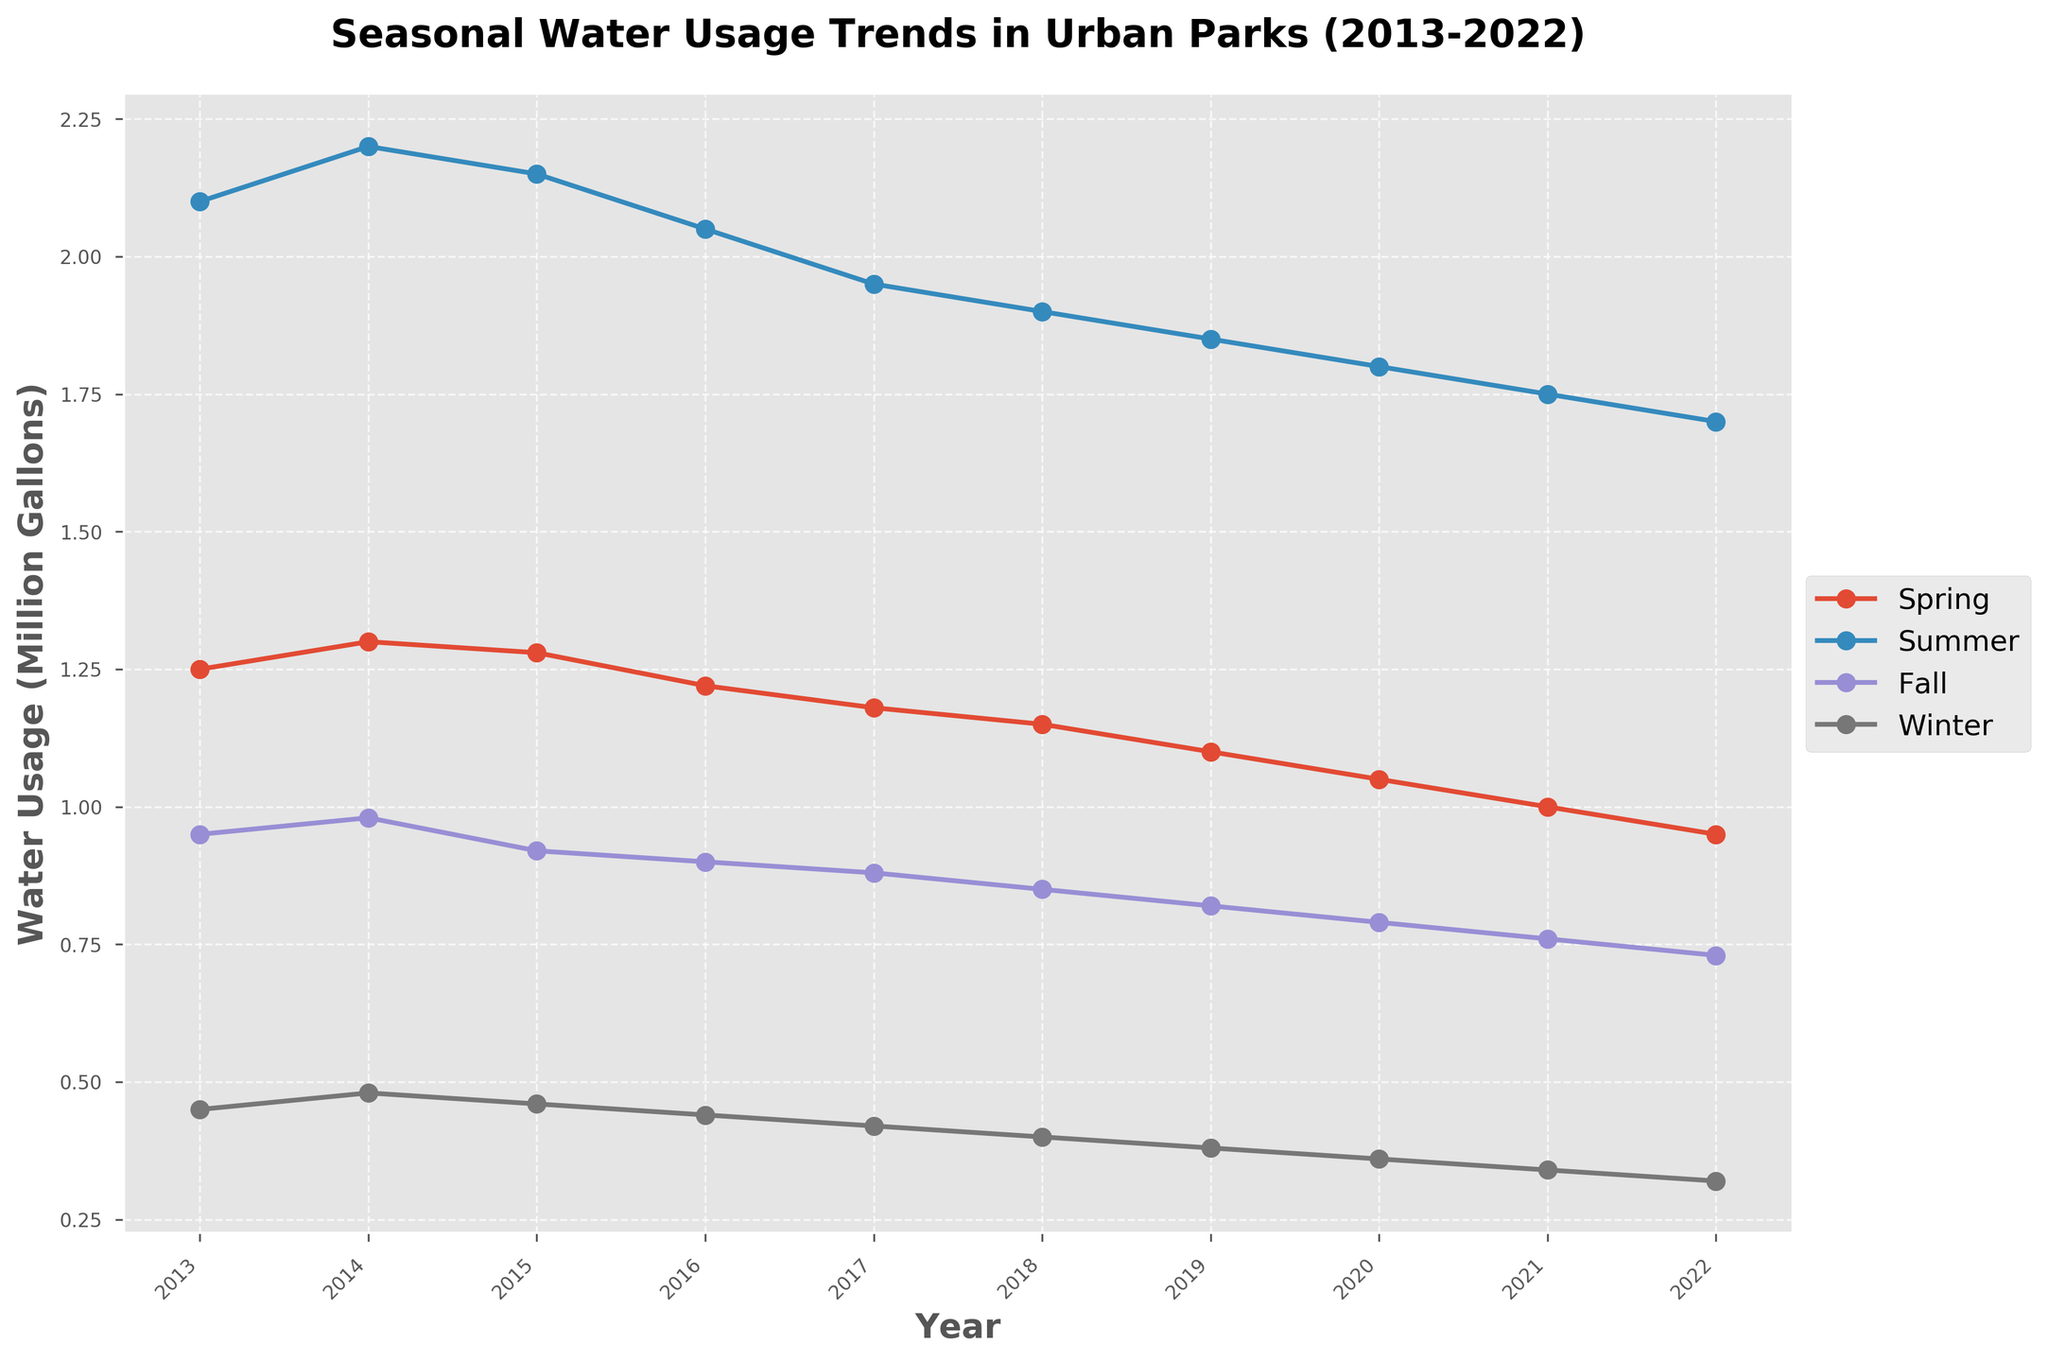What season had the highest water usage in 2013? The plot shows that in 2013, the season with the highest water usage is depicted with the highest peak on the line chart for that year. The highest peak is observed in Summer.
Answer: Summer Which season consistently used the least water across all years? By analyzing the plot, we observe the position of the lines corresponding to each season over the 10-year period. The Winter line is consistently the lowest, indicating the least water usage.
Answer: Winter How did the water usage in Summer change from 2013 to 2022? To determine the change in water usage, we refer to the Summer line on the plot and note the values for 2013 and 2022. The usage starts at a high value in 2013 and shows a gradual decline until 2022.
Answer: Declined What is the average water usage for Spring across the 10 years? We find the data points for Spring on the plot and add them up, then divide by 10. The average calculation is: (1.25 + 1.3 + 1.28 + 1.22 + 1.18 + 1.15 + 1.1 + 1.05 + 1 + 0.95)/10 million gallons.
Answer: 1.148 million gallons Which season shows the most significant reduction in water usage from the maximum to the minimum? By visually inspecting the peaks and troughs of each season on the plot, we can observe that the most dramatic reduction is in Winter, from the highest usage to the lowest usage.
Answer: Winter What was the total water usage in Fall for the years where the usage was below 1 million gallons? Identify the years where Fall's water usage is below 1 million gallons on the plot. Sum these values: 950,000 in 2013, 980,000 in 2014, 920,000 in 2015, 900,000 in 2016, 880,000 in 2017, 850,000 in 2018, 820,000 in 2019, 790,000 in 2020, 760,000 in 2021, and 730,000 in 2022. Total = (950 + 980 + 920 + 900 + 880 + 850 + 820 + 790 + 760 + 730) thousand gallons.
Answer: 8.58 million gallons How does the highest water usage in Spring compare to the highest in Fall? Identify the highest points on the Spring and Fall lines on the plot and compare them. The highest for Spring is in 2014, around 1.3 million gallons, and Fall is in 2014, around 0.98 million gallons.
Answer: Spring is higher What is the difference in water usage between Summer and Winter in 2022? Identify the points for Summer and Winter in 2022 on the plot and calculate the difference. Summer is around 1.7 million gallons, and Winter is around 0.32 million gallons. Difference = 1.7 - 0.32.
Answer: 1.38 million gallons What trend is observed in water usage for Winter from 2013 to 2022? Follow the Winter line on the plot from 2013 to 2022. It starts around 0.45 million gallons in 2013 and decreases steadily over the years to approximately 0.32 million gallons in 2022.
Answer: Decreasing 